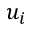Convert formula to latex. <formula><loc_0><loc_0><loc_500><loc_500>u _ { i }</formula> 